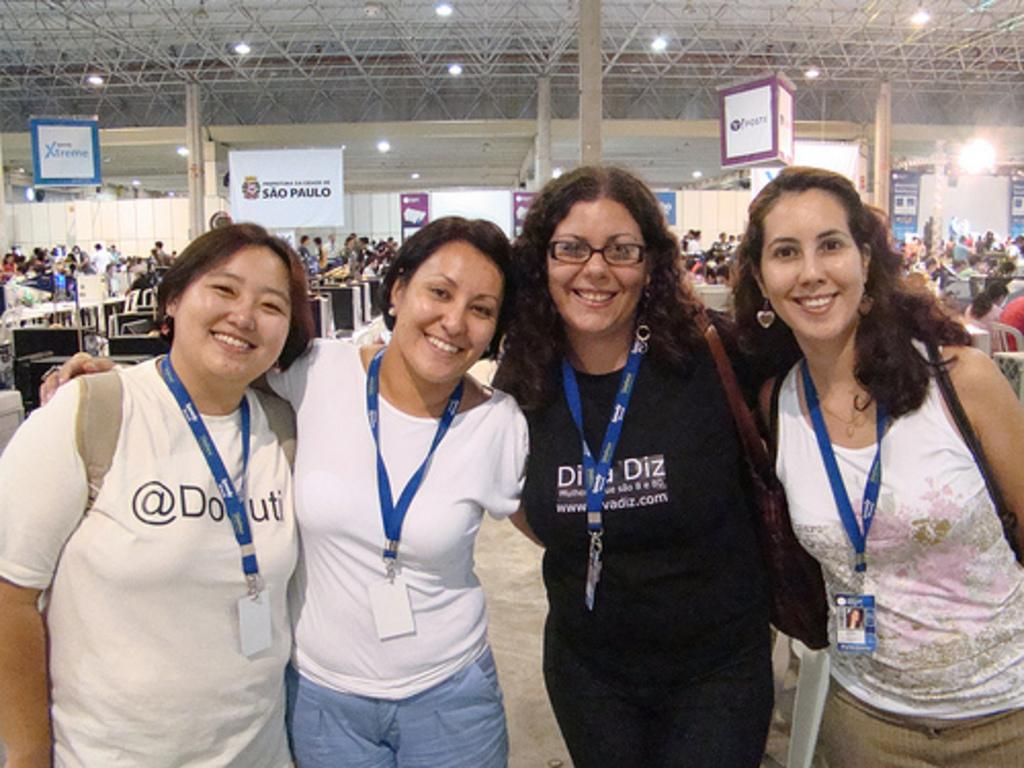<image>
Provide a brief description of the given image. a banner that says sal paulo hangs in the background 